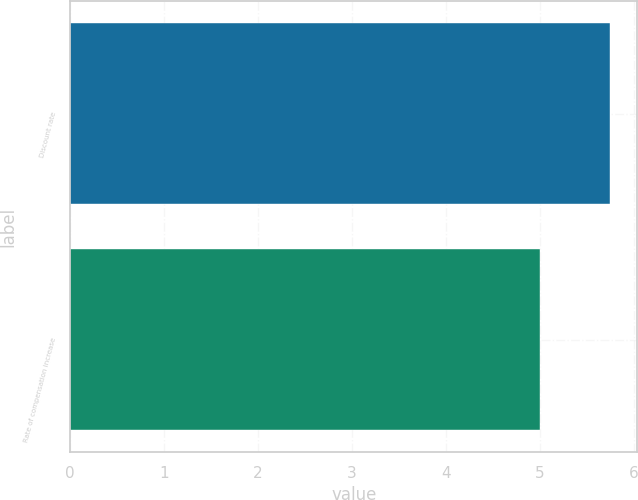Convert chart. <chart><loc_0><loc_0><loc_500><loc_500><bar_chart><fcel>Discount rate<fcel>Rate of compensation increase<nl><fcel>5.75<fcel>5<nl></chart> 